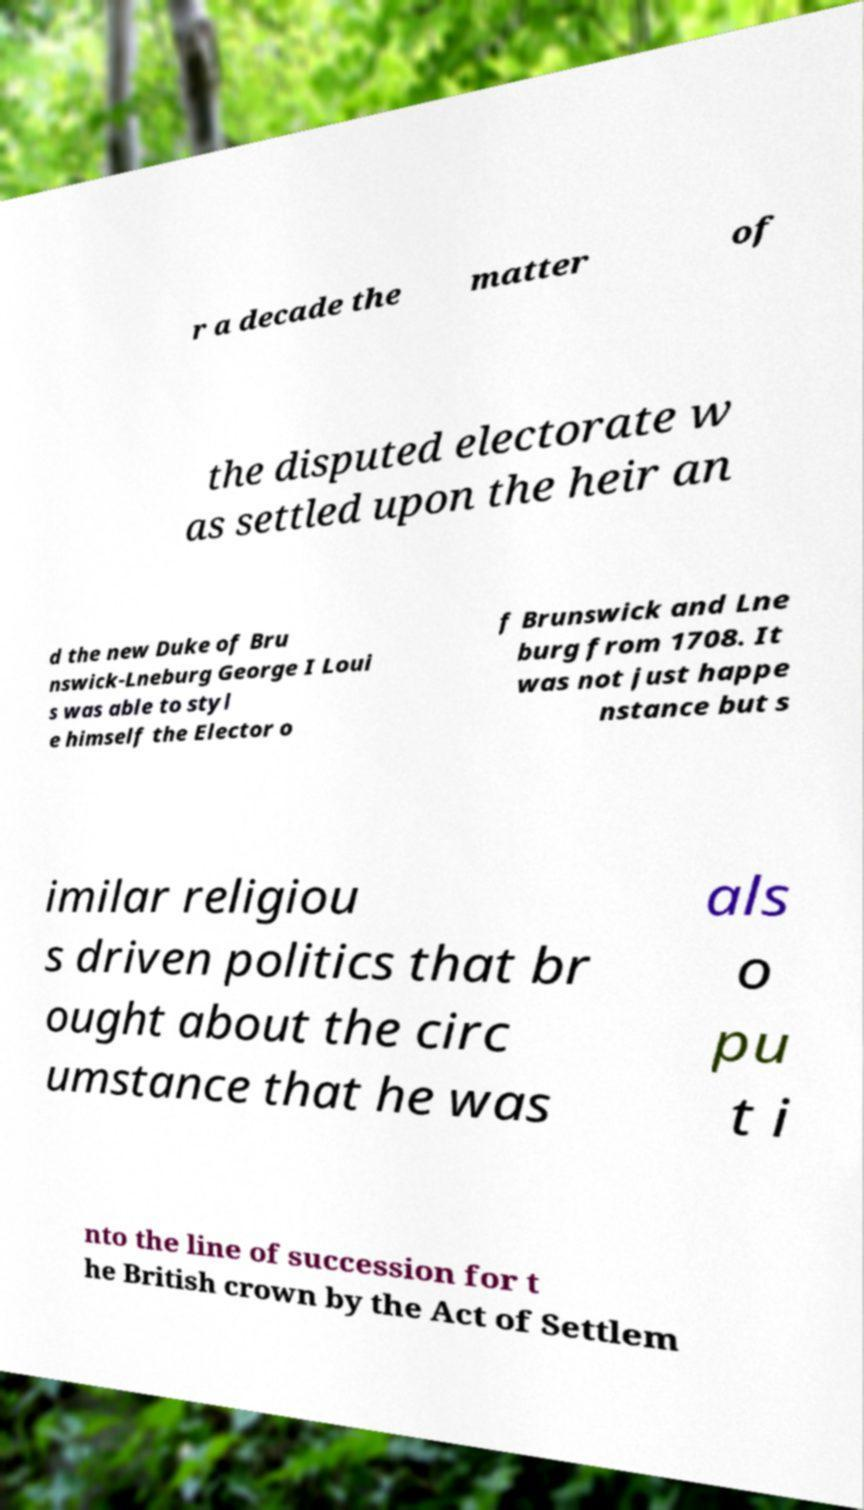Please read and relay the text visible in this image. What does it say? r a decade the matter of the disputed electorate w as settled upon the heir an d the new Duke of Bru nswick-Lneburg George I Loui s was able to styl e himself the Elector o f Brunswick and Lne burg from 1708. It was not just happe nstance but s imilar religiou s driven politics that br ought about the circ umstance that he was als o pu t i nto the line of succession for t he British crown by the Act of Settlem 